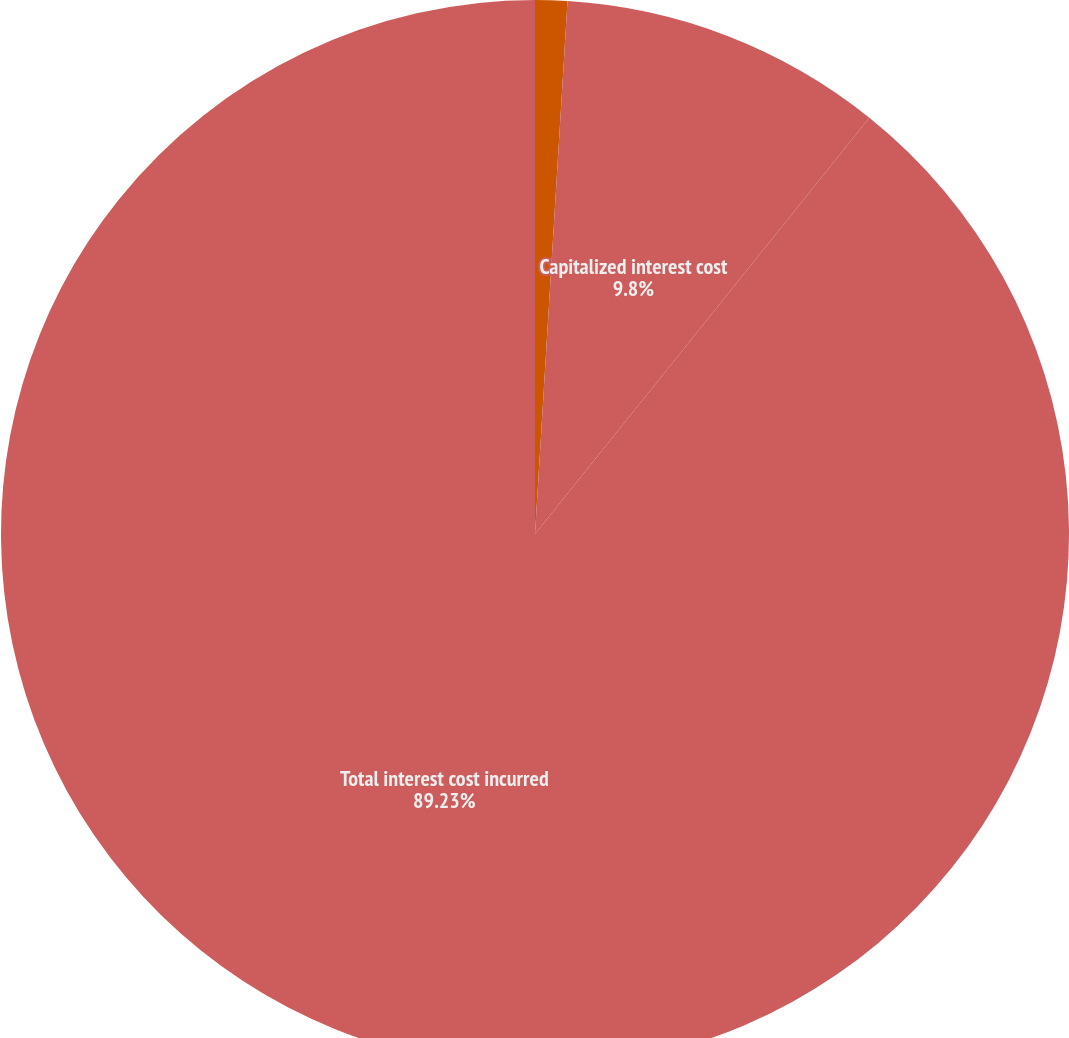<chart> <loc_0><loc_0><loc_500><loc_500><pie_chart><fcel>in thousands<fcel>Capitalized interest cost<fcel>Total interest cost incurred<nl><fcel>0.97%<fcel>9.8%<fcel>89.24%<nl></chart> 